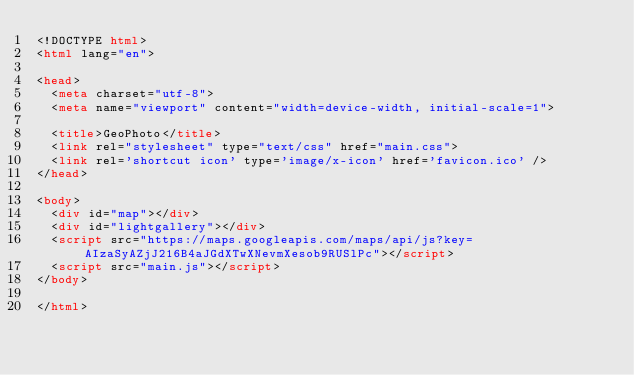<code> <loc_0><loc_0><loc_500><loc_500><_HTML_><!DOCTYPE html>
<html lang="en">

<head>
  <meta charset="utf-8">
  <meta name="viewport" content="width=device-width, initial-scale=1">

  <title>GeoPhoto</title>
  <link rel="stylesheet" type="text/css" href="main.css">
  <link rel='shortcut icon' type='image/x-icon' href='favicon.ico' />
</head>

<body>
  <div id="map"></div>
  <div id="lightgallery"></div>
  <script src="https://maps.googleapis.com/maps/api/js?key=AIzaSyAZjJ216B4aJGdXTwXNevmXesob9RUSlPc"></script>
  <script src="main.js"></script>
</body>

</html>
</code> 